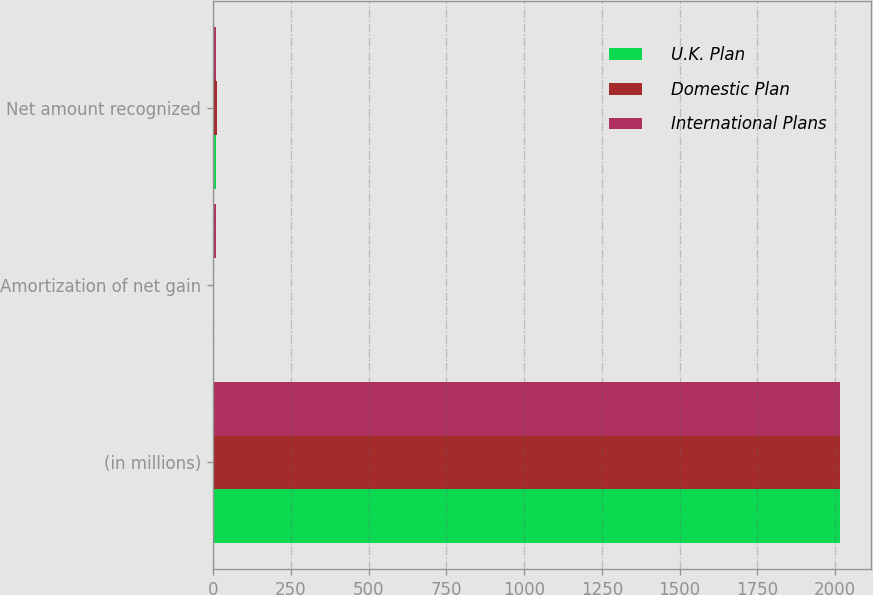Convert chart. <chart><loc_0><loc_0><loc_500><loc_500><stacked_bar_chart><ecel><fcel>(in millions)<fcel>Amortization of net gain<fcel>Net amount recognized<nl><fcel>U.K. Plan<fcel>2015<fcel>3<fcel>8<nl><fcel>Domestic Plan<fcel>2015<fcel>2<fcel>14<nl><fcel>International Plans<fcel>2015<fcel>9<fcel>8<nl></chart> 